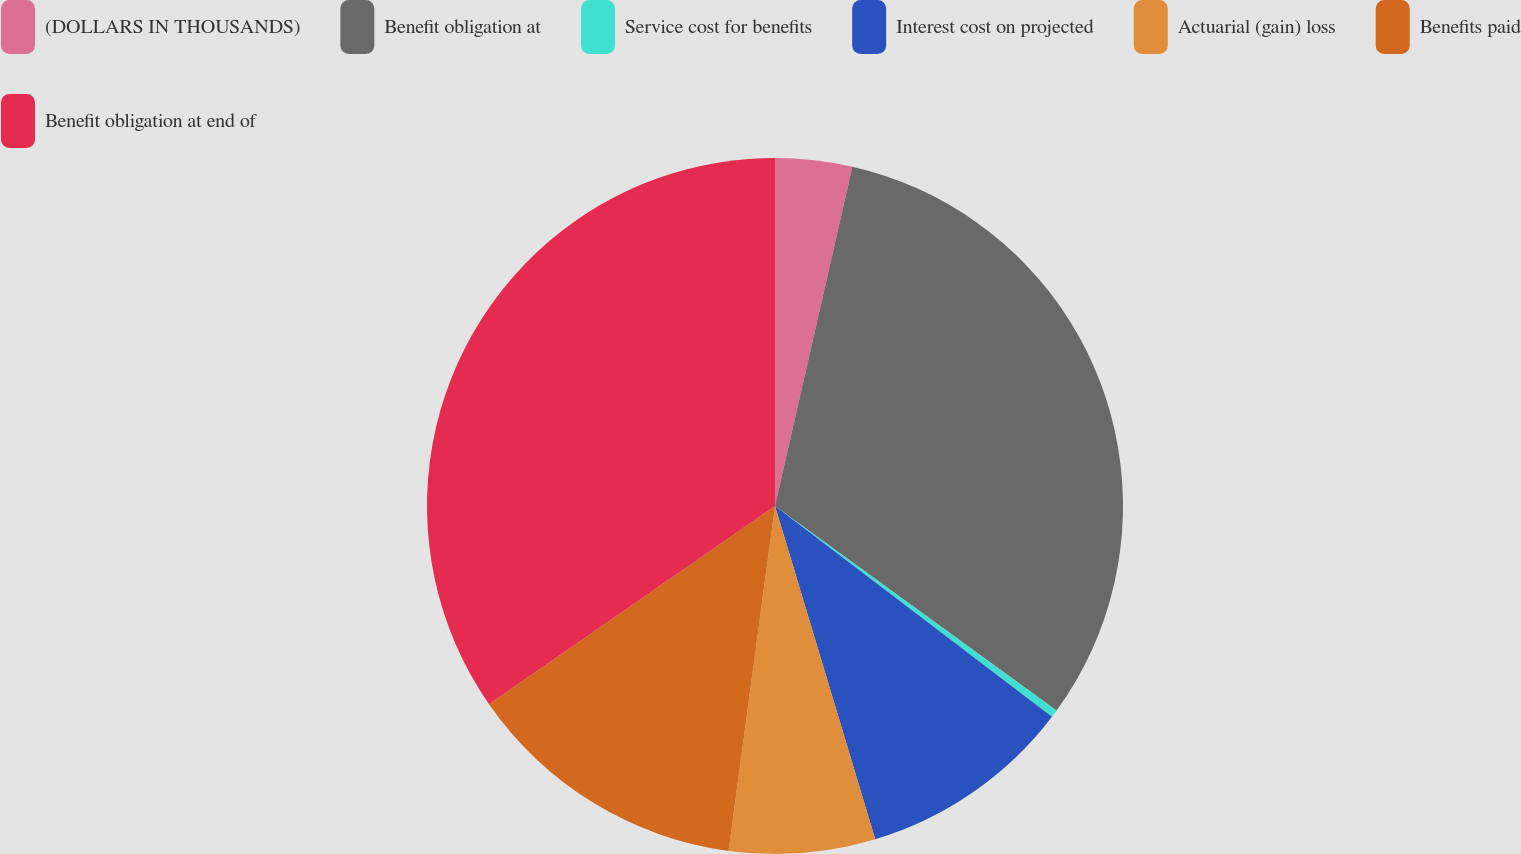Convert chart to OTSL. <chart><loc_0><loc_0><loc_500><loc_500><pie_chart><fcel>(DOLLARS IN THOUSANDS)<fcel>Benefit obligation at<fcel>Service cost for benefits<fcel>Interest cost on projected<fcel>Actuarial (gain) loss<fcel>Benefits paid<fcel>Benefit obligation at end of<nl><fcel>3.57%<fcel>31.43%<fcel>0.35%<fcel>10.0%<fcel>6.78%<fcel>13.22%<fcel>34.65%<nl></chart> 